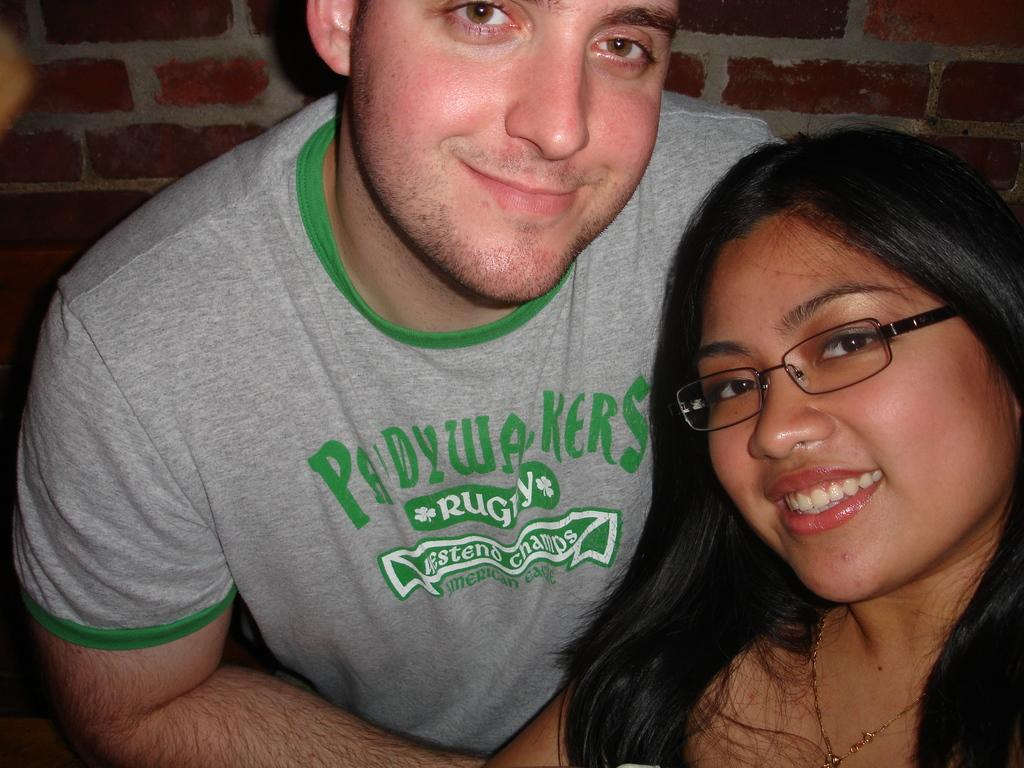Who are the people in the foreground of the image? There is a woman and a man in the foreground of the image. What are the woman and the man doing in the image? Both the woman and the man are posing for the camera. What can be seen in the background of the image? There is a brick wall in the background of the image. What type of bun is the woman holding in the image? There is no bun present in the image; the woman and the man are posing for the camera. How does the man express his anger in the image? There is no indication of anger in the image; both the woman and the man are posing for the camera with neutral expressions. 